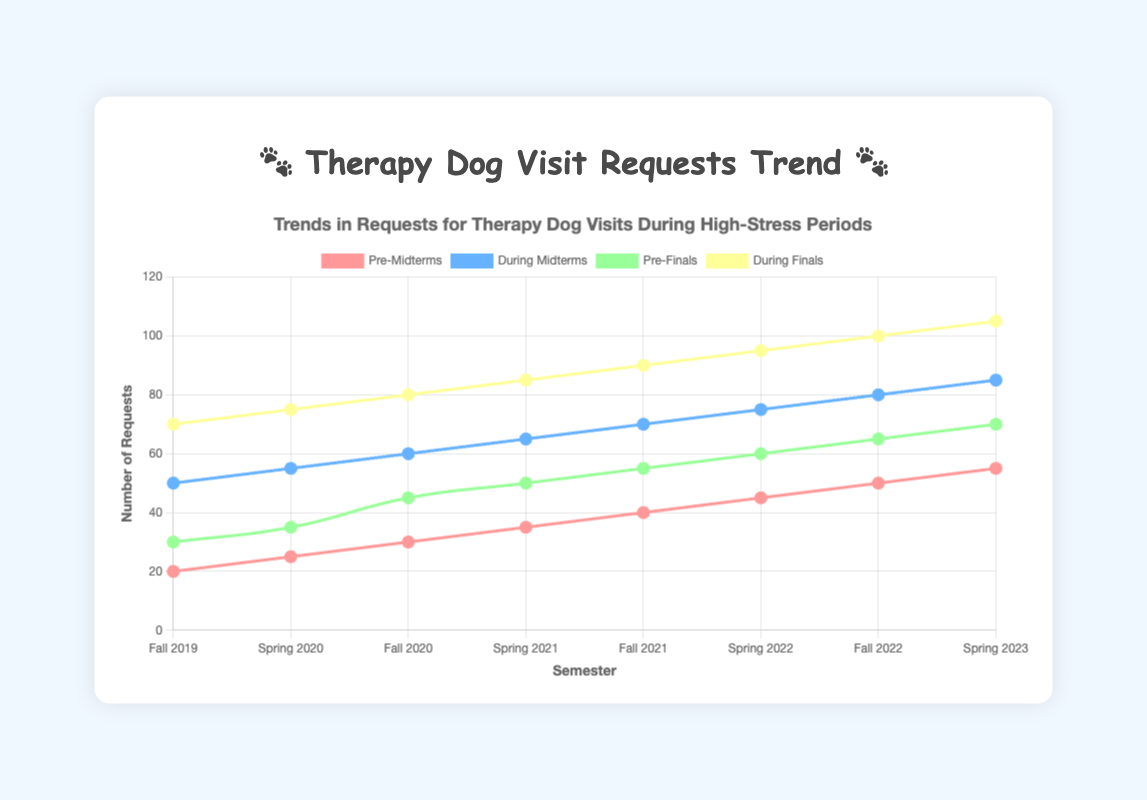What's the trend in requests for therapy dog visits during finals from Fall 2019 to Spring 2023? The requests increased consistently from 70 in Fall 2019 to 105 in Spring 2023. This shows that students increasingly sought therapy dog visits during finals.
Answer: Increasing Between Pre-Midterms and During Midterms, which period had the higher number of requests in Spring 2022? In Spring 2022, Pre-Midterms had 45 requests, and During Midterms had 75 requests. 75 is greater than 45.
Answer: During Midterms Which semester had the least requests during Midterms? Fall 2019 had the least requests during Midterms with 50 requests.
Answer: Fall 2019 What is the total number of requests during finals across all semesters? The requests during finals for each semester are: 70, 75, 80, 85, 90, 95, 100, and 105. Summing these values (70 + 75 + 80 + 85 + 90 + 95 + 100 + 105) gives 700.
Answer: 700 Which period had the highest single-semester number of requests? The highest single-semester number of requests was During Finals in Spring 2023 with 105 requests.
Answer: During Finals in Spring 2023 What is the difference in requests between Pre-Finals and During Finals in Fall 2022? In Fall 2022, Pre-Finals had 65 requests and During Finals had 100 requests. The difference is 100 - 65 = 35.
Answer: 35 Which color represents the Pre-Midterms data line? The color representing the Pre-Midterms data line is a shade of red.
Answer: Red Across which periods did the number of requests exactly increase by 5 each semester? The number of requests for Pre-Midterms and During Midterms increased by 5 each semester.
Answer: Pre-Midterms and During Midterms How many more requests were there During Finals compared to Pre-Finals in Spring 2021? In Spring 2021, there were 85 requests During Finals and 50 requests Pre-Finals. The difference is 85 - 50 = 35.
Answer: 35 What is the average number of requests during Pre-Finals across all semesters? The number of requests during Pre-Finals for each semester are: 30, 35, 45, 50, 55, 60, 65, and 70. Summing them gives (30 + 35 + 45 + 50 + 55 + 60 + 65 + 70) = 410. Dividing by the 8 semesters, the average is 410 / 8 = 51.25.
Answer: 51.25 